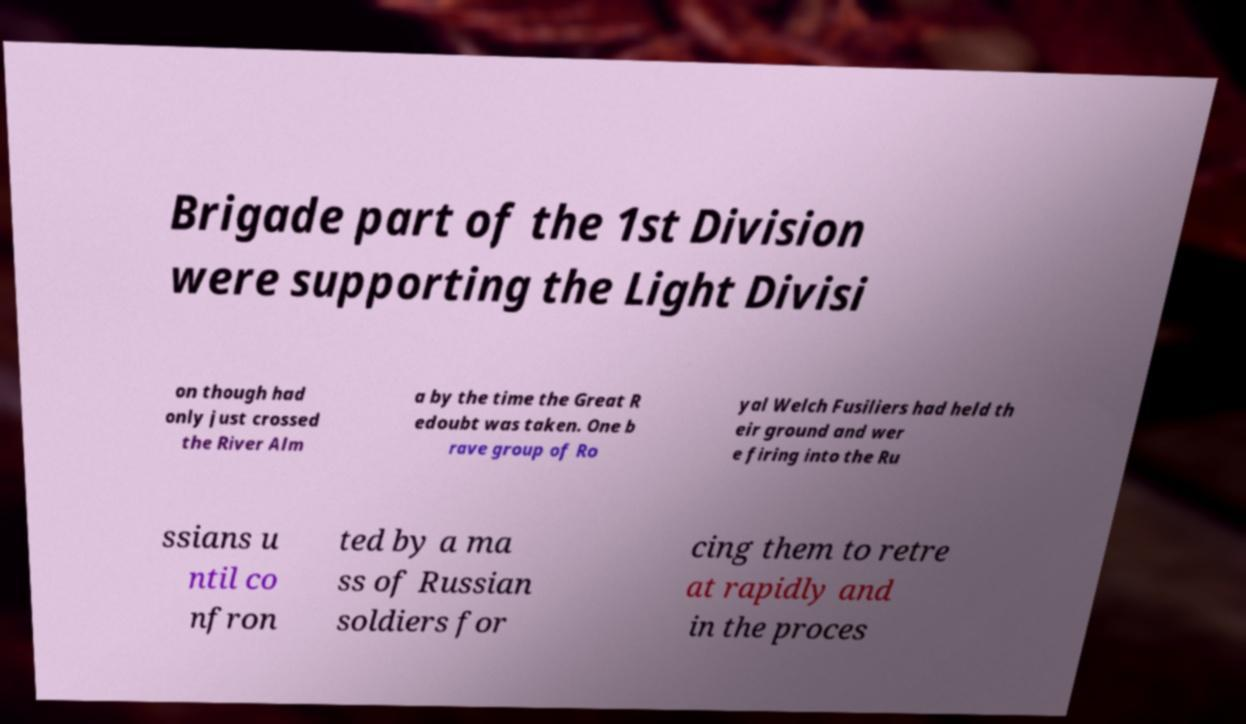There's text embedded in this image that I need extracted. Can you transcribe it verbatim? Brigade part of the 1st Division were supporting the Light Divisi on though had only just crossed the River Alm a by the time the Great R edoubt was taken. One b rave group of Ro yal Welch Fusiliers had held th eir ground and wer e firing into the Ru ssians u ntil co nfron ted by a ma ss of Russian soldiers for cing them to retre at rapidly and in the proces 